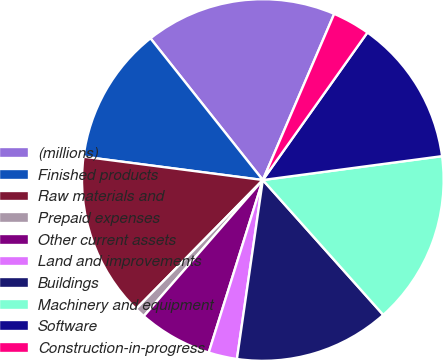Convert chart to OTSL. <chart><loc_0><loc_0><loc_500><loc_500><pie_chart><fcel>(millions)<fcel>Finished products<fcel>Raw materials and<fcel>Prepaid expenses<fcel>Other current assets<fcel>Land and improvements<fcel>Buildings<fcel>Machinery and equipment<fcel>Software<fcel>Construction-in-progress<nl><fcel>17.13%<fcel>12.27%<fcel>14.7%<fcel>0.93%<fcel>6.6%<fcel>2.55%<fcel>13.89%<fcel>15.51%<fcel>13.08%<fcel>3.36%<nl></chart> 